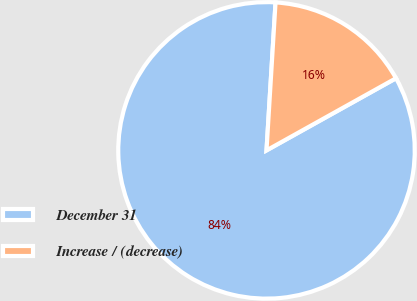Convert chart to OTSL. <chart><loc_0><loc_0><loc_500><loc_500><pie_chart><fcel>December 31<fcel>Increase / (decrease)<nl><fcel>84.06%<fcel>15.94%<nl></chart> 